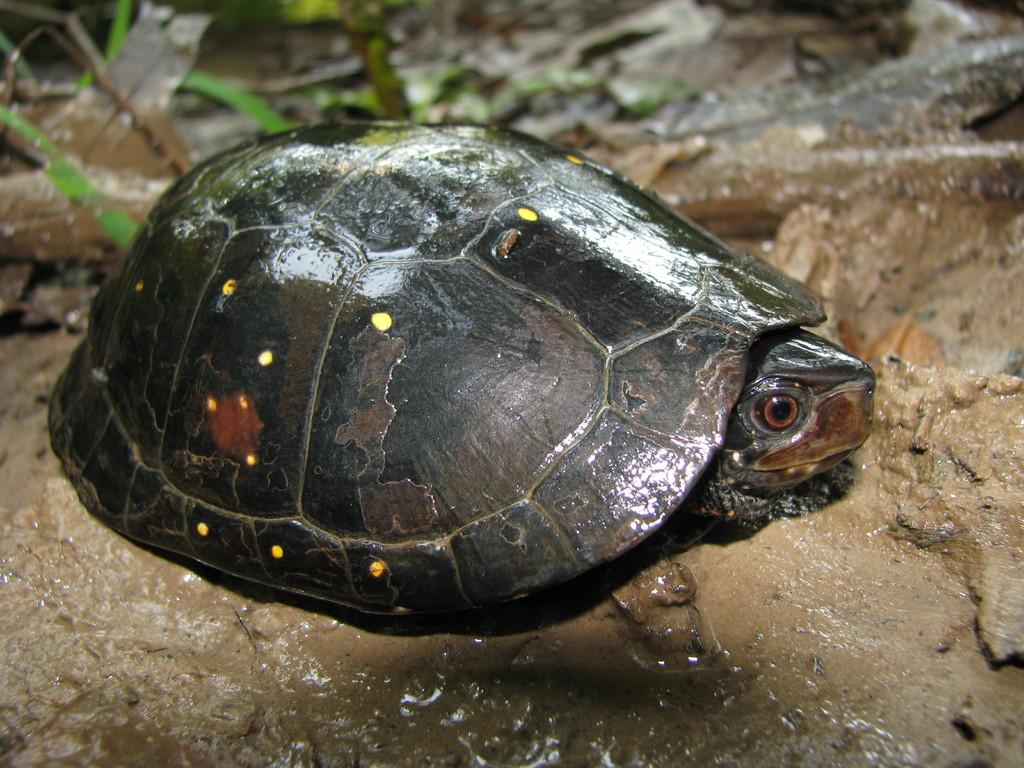What type of animal is in the image? There is a tortoise in the image. What is the tortoise standing on? The tortoise is on the mud. What type of sheet is covering the rock in the image? There is no sheet or rock present in the image; it only features a tortoise on the mud. 